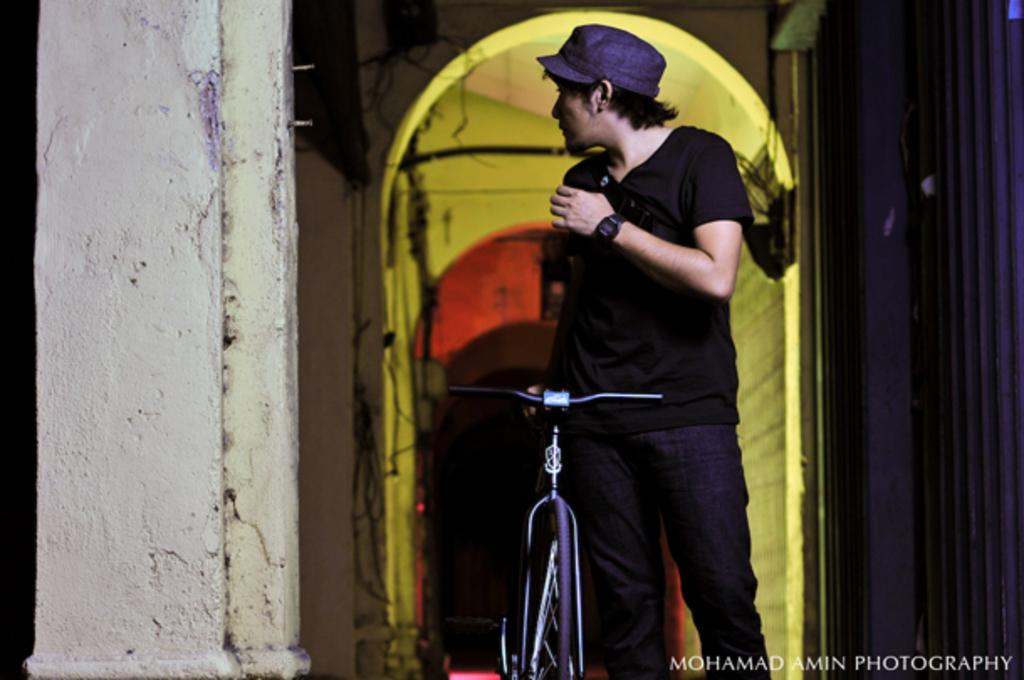What is the main subject of the image? There is a person in the image. What is the person doing in the image? The person is standing with a bicycle. What can be seen in the background of the image? There are walls and cables visible in the image. Is there any indication of the image's condition or quality? Yes, there is a water mark on the bottom of the image. How many sisters does the person in the image have? There is no information about the person's sisters in the image. What is the chance of rain in the image? There is no indication of weather or chance of rain in the image. 